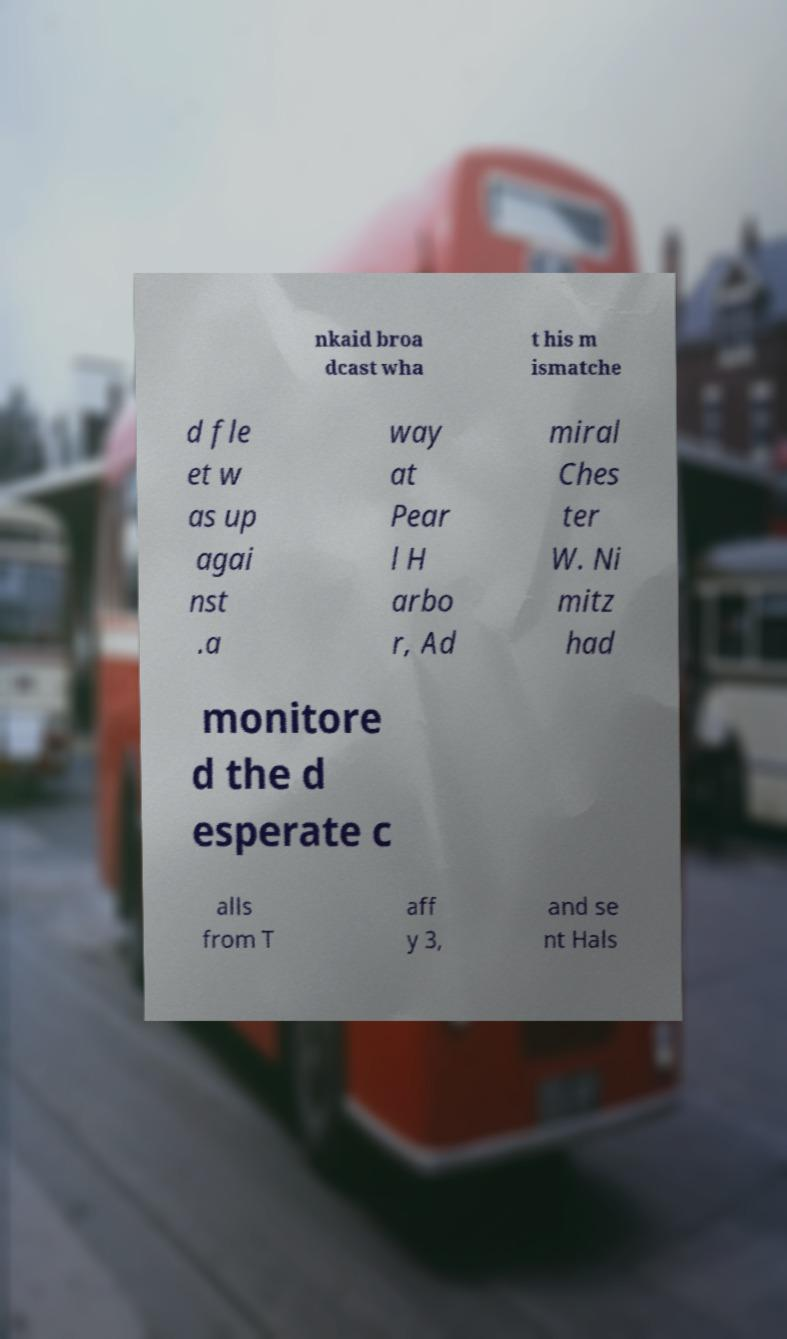Can you accurately transcribe the text from the provided image for me? nkaid broa dcast wha t his m ismatche d fle et w as up agai nst .a way at Pear l H arbo r, Ad miral Ches ter W. Ni mitz had monitore d the d esperate c alls from T aff y 3, and se nt Hals 